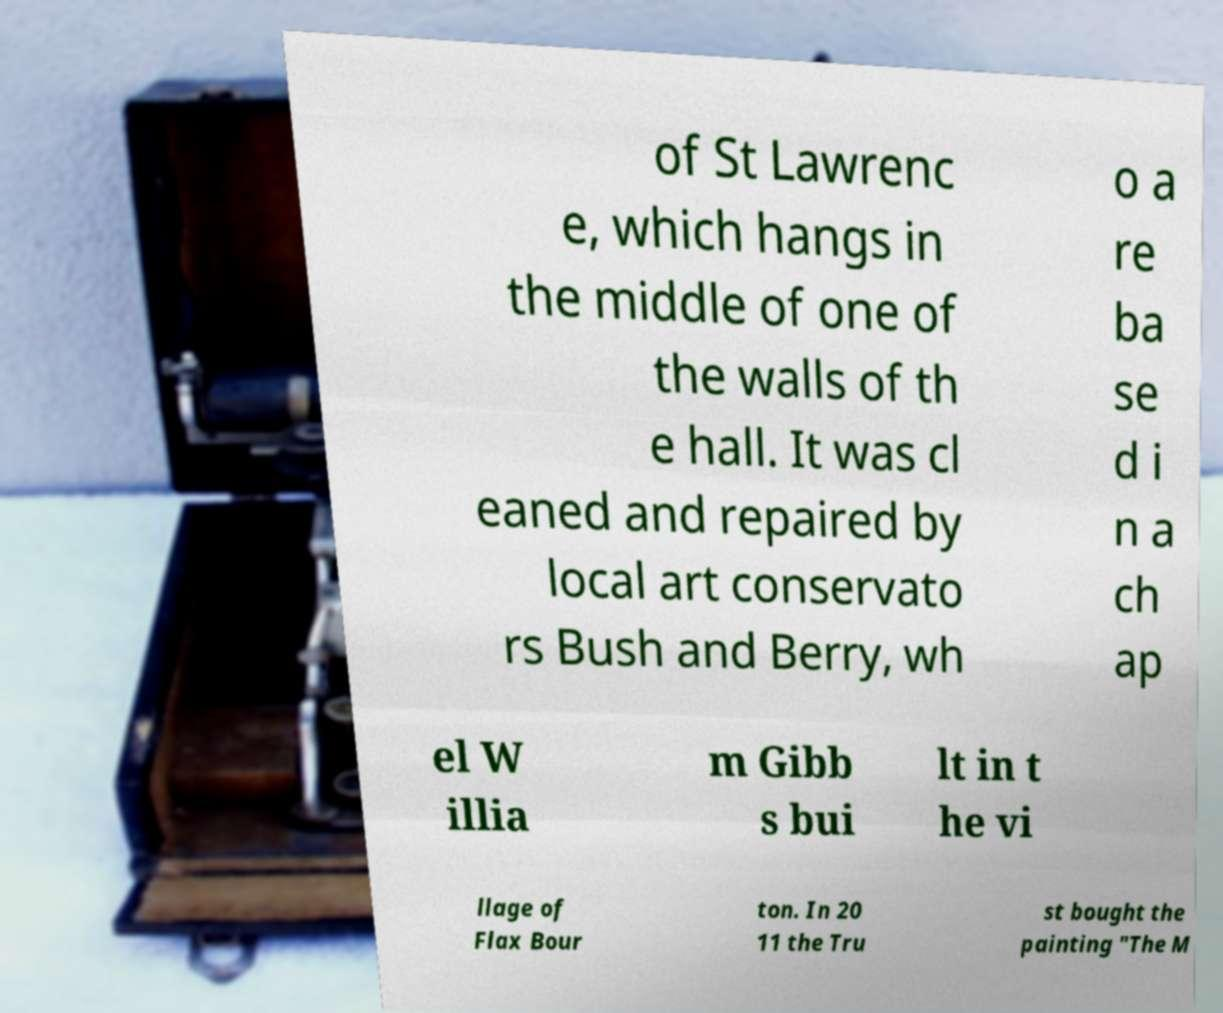Could you assist in decoding the text presented in this image and type it out clearly? of St Lawrenc e, which hangs in the middle of one of the walls of th e hall. It was cl eaned and repaired by local art conservato rs Bush and Berry, wh o a re ba se d i n a ch ap el W illia m Gibb s bui lt in t he vi llage of Flax Bour ton. In 20 11 the Tru st bought the painting "The M 